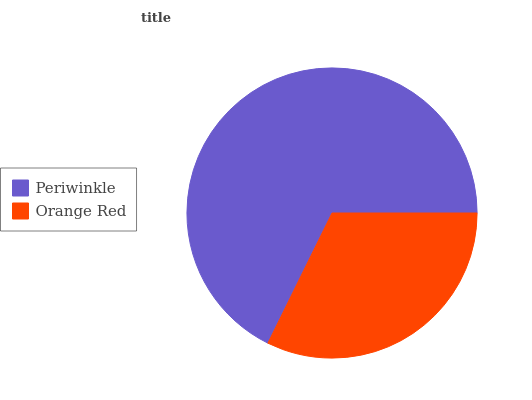Is Orange Red the minimum?
Answer yes or no. Yes. Is Periwinkle the maximum?
Answer yes or no. Yes. Is Orange Red the maximum?
Answer yes or no. No. Is Periwinkle greater than Orange Red?
Answer yes or no. Yes. Is Orange Red less than Periwinkle?
Answer yes or no. Yes. Is Orange Red greater than Periwinkle?
Answer yes or no. No. Is Periwinkle less than Orange Red?
Answer yes or no. No. Is Periwinkle the high median?
Answer yes or no. Yes. Is Orange Red the low median?
Answer yes or no. Yes. Is Orange Red the high median?
Answer yes or no. No. Is Periwinkle the low median?
Answer yes or no. No. 